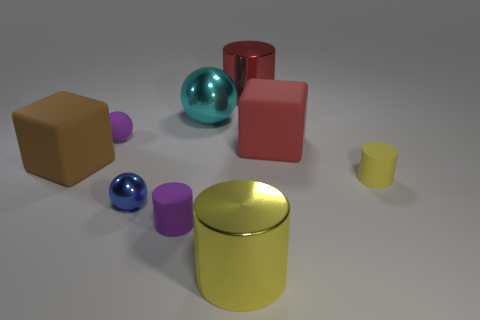What could be the material of these objects, based on their appearance? Based on the image, the objects appear to have different materials. The balls and the bright yellow cylinder have a reflective surface that might suggest a metallic or polished plastic material. The cubes and the small pink cylinder seem to have a matte finish and could be made of a solid, non-reflective material like wood or unglazed ceramic. 